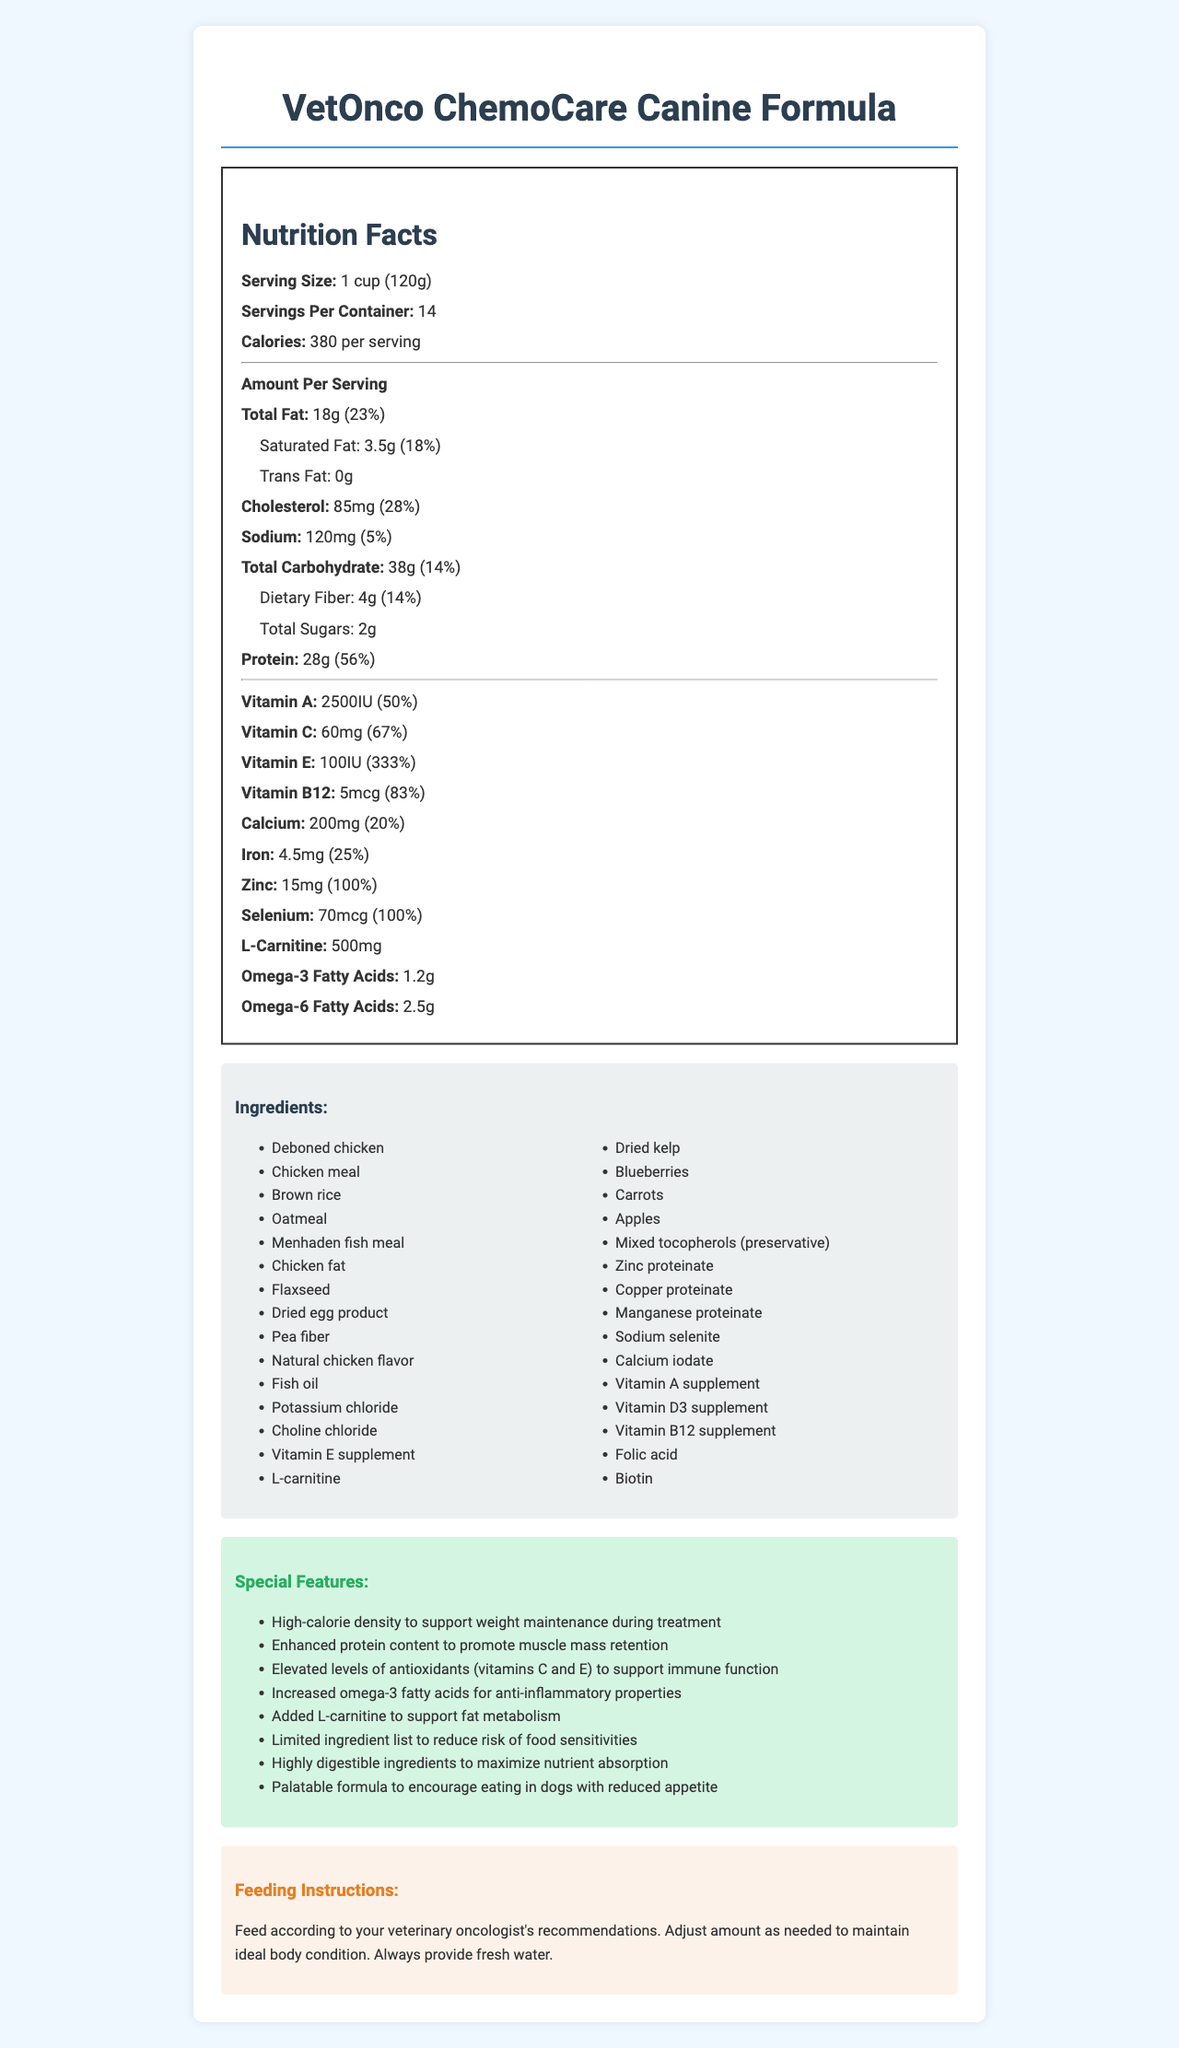what is the serving size for VetOnco ChemoCare Canine Formula? The serving size is clearly stated as 1 cup (120g) in the document.
Answer: 1 cup (120g) how many calories are in one serving? The document specifies that there are 380 calories per serving.
Answer: 380 what is the total fat content per serving? The total fat content per serving is listed as 18g in the document.
Answer: 18g how much protein is in each serving? The document indicates that each serving contains 28g of protein.
Answer: 28g what is the daily value percentage of vitamin C per serving? The daily value percentage for vitamin C is specified as 67% per serving.
Answer: 67% which of the following nutrients has the highest daily value percentage per serving? A. Calcium B. Iron C. Vitamin E D. Zinc The daily value percentage for vitamin E is the highest at 333%.
Answer: C how many servings are there per container? The document states that there are 14 servings per container.
Answer: 14 is trans fat present in this pet food? The document clearly states that the trans fat content is 0g.
Answer: No what ingredients in the pet food contribute to its high antioxidant content? A. Choline chloride, Fish oil B. Dried kelp, Blueberries C. Pea fiber, Oatmeal D. Chicken fat, Potassium chloride Blueberries and dried kelp contribute to the high antioxidant content.
Answer: B is the protein content in VetOnco ChemoCare Canine Formula more than the carbohydrate content? The document shows that the protein content is 28g, and the carbohydrate content is 38g, so the protein content is not more than the carbohydrate content.
Answer: No how many types of vitamins are explicitly listed in the nutritional information? The vitamins listed are vitamin A, vitamin C, vitamin E, vitamin B12, and folic acid.
Answer: 5 what is the purpose of L-carnitine in the pet food? The document mentions that L-carnitine is added to support fat metabolism.
Answer: To support fat metabolism what is the main idea of the document? The document's purpose is to present comprehensive nutritional information for a specialized pet food aimed at supporting dogs going through chemotherapy, highlighting its high-calorie density, enhanced protein, antioxidants, and special features for health benefits.
Answer: The document provides detailed nutritional information about VetOnco ChemoCare Canine Formula, a specialized pet food designed for dogs undergoing chemotherapy. It includes serving size, caloric content, macronutrients, micronutrients, ingredients, special features, and feeding instructions. what is the exact amount of L-carnitine per serving in the pet food? The document specifies that there are 500mg of L-carnitine per serving.
Answer: 500mg can you determine the production date of VetOnco ChemoCare Canine Formula from the document? The document does not contain any information regarding the production date.
Answer: Cannot be determined how should the feeding amount be adjusted for a dog? The feeding instructions mention adjusting the amount as needed to maintain the dog's ideal body condition and always providing fresh water.
Answer: Adjust amount as needed to maintain ideal body condition. Always provide fresh water. are omega-3 fatty acids more or less than omega-6 fatty acids in this pet food? The document states that omega-3 fatty acids are 1.2g and omega-6 fatty acids are 2.5g, making omega-3 fatty acids less than omega-6 fatty acids.
Answer: Less 